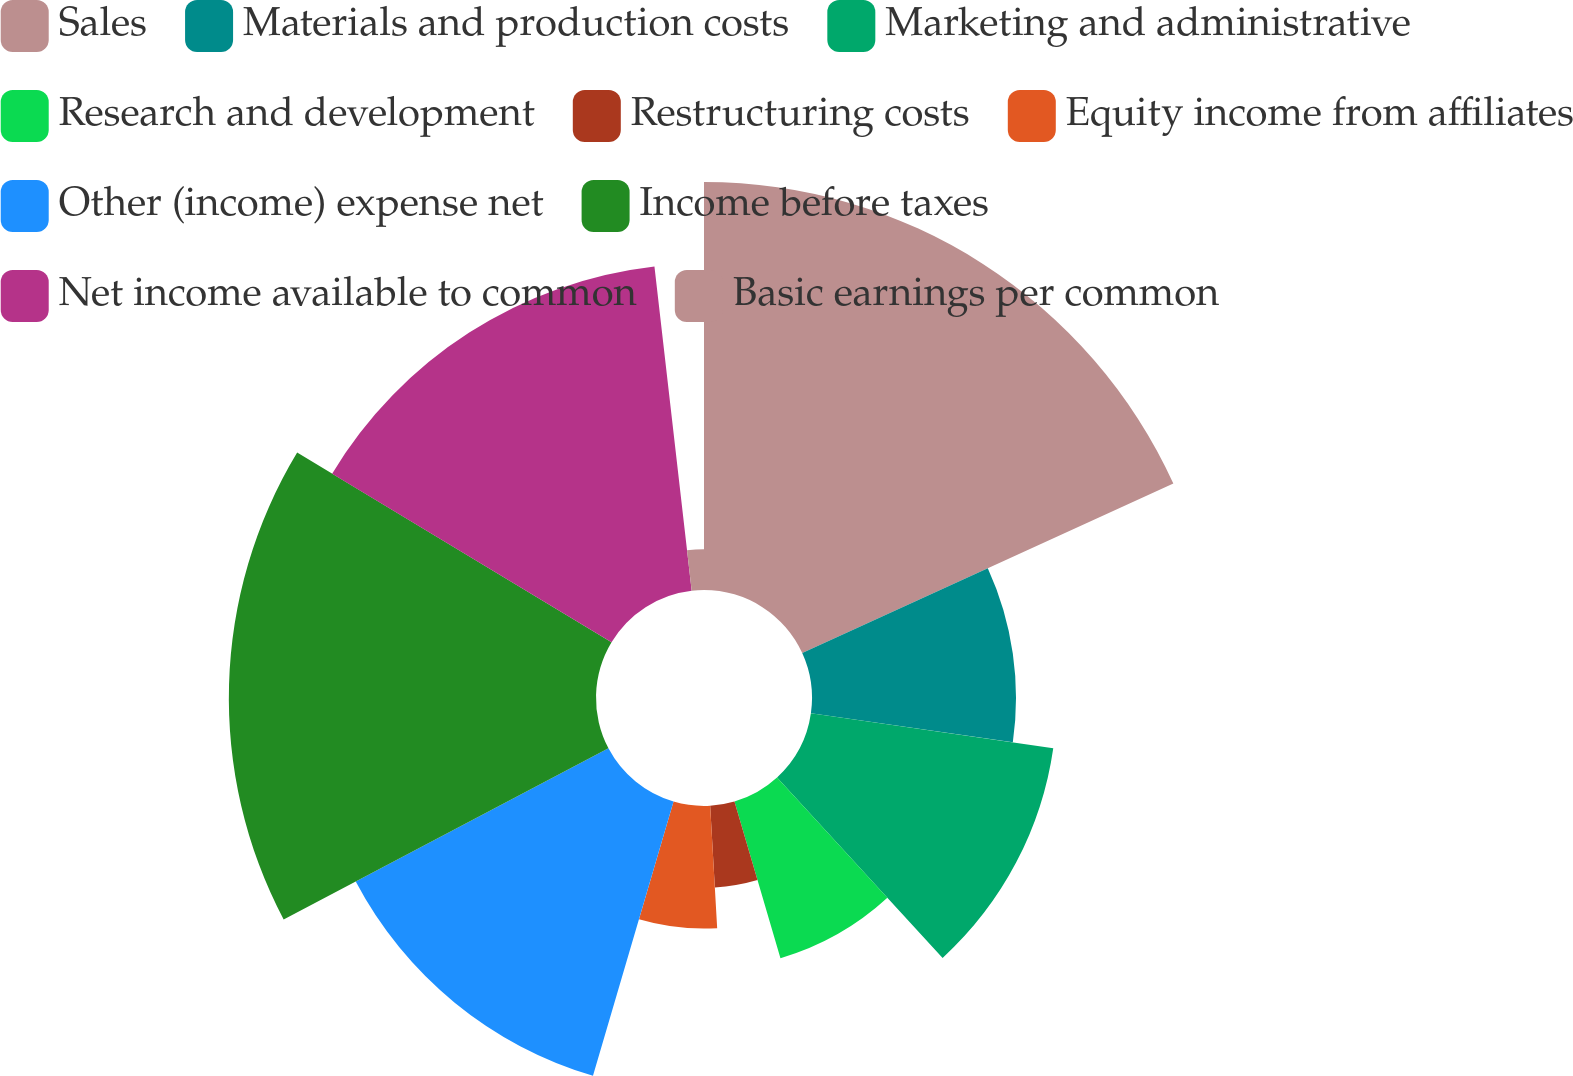Convert chart to OTSL. <chart><loc_0><loc_0><loc_500><loc_500><pie_chart><fcel>Sales<fcel>Materials and production costs<fcel>Marketing and administrative<fcel>Research and development<fcel>Restructuring costs<fcel>Equity income from affiliates<fcel>Other (income) expense net<fcel>Income before taxes<fcel>Net income available to common<fcel>Basic earnings per common<nl><fcel>18.18%<fcel>9.09%<fcel>10.91%<fcel>7.27%<fcel>3.64%<fcel>5.46%<fcel>12.73%<fcel>16.36%<fcel>14.54%<fcel>1.82%<nl></chart> 